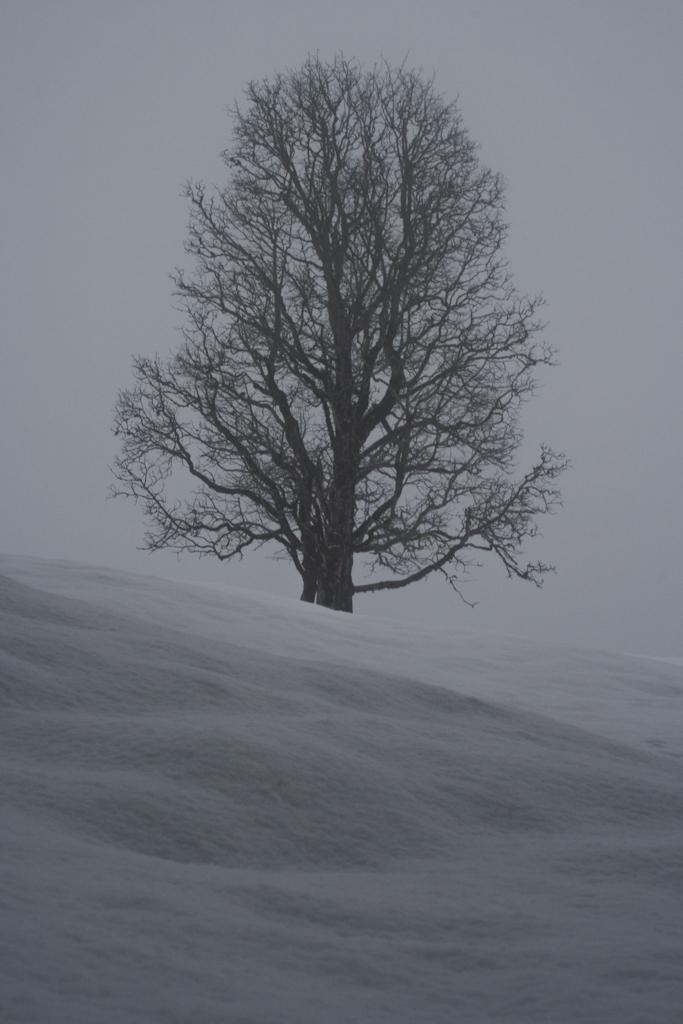What type of natural environment is depicted in the image? The image features snow, which suggests a cold or wintery environment. What can be seen in the background of the image? There is a tree in the background of the image. How many fingers can be seen in the image? There are no fingers visible in the image. What type of island is depicted in the image? There is no island present in the image. Is there a fireman visible in the image? There is no fireman present in the image. 